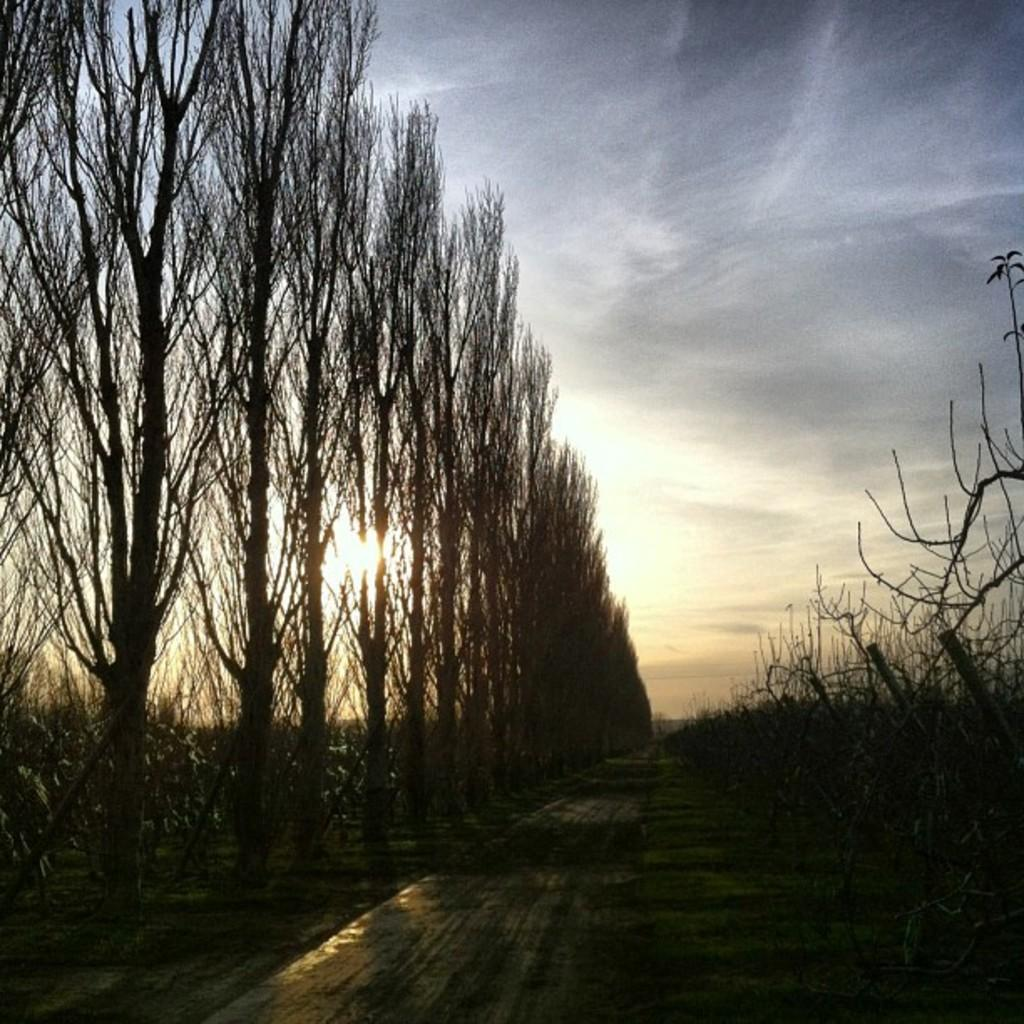What time of day was the image taken? The image was taken during the evening time. What type of natural environment is visible in the image? There are many trees in the image, indicating a forest or wooded area. What is visible at the bottom of the image? There is a road visible at the bottom of the image. What can be seen in the sky in the image? The sky is visible in the background of the image, and the sun is observable. How many cabbages are being used as a cent in the image? There are no cabbages or cents present in the image. How many cars are visible in the image? There are no cars visible in the image; it primarily features trees, a road, and the sky. 